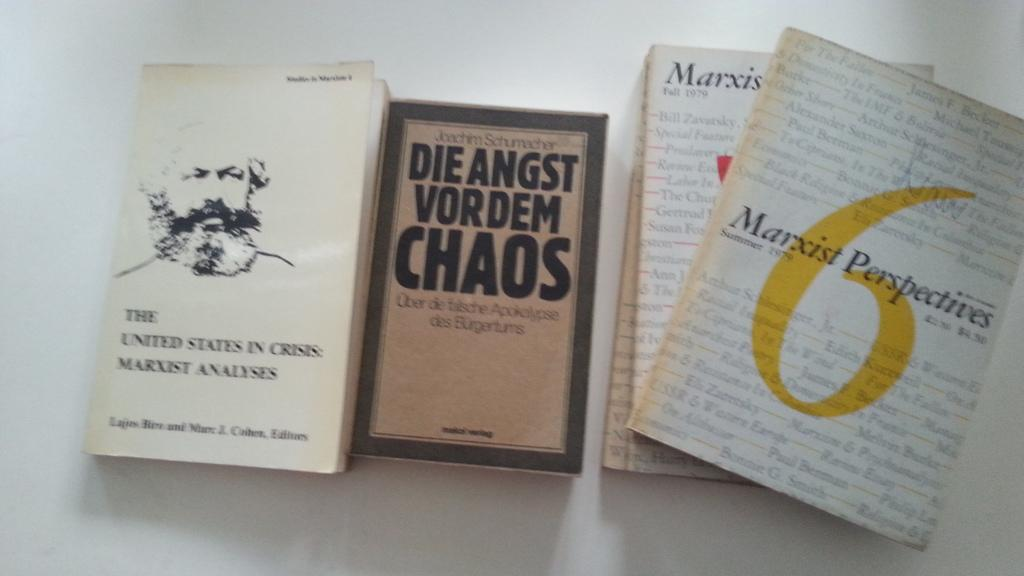<image>
Offer a succinct explanation of the picture presented. Die Angst Vordem Chaos chapter book by Joachim Schumacher. 